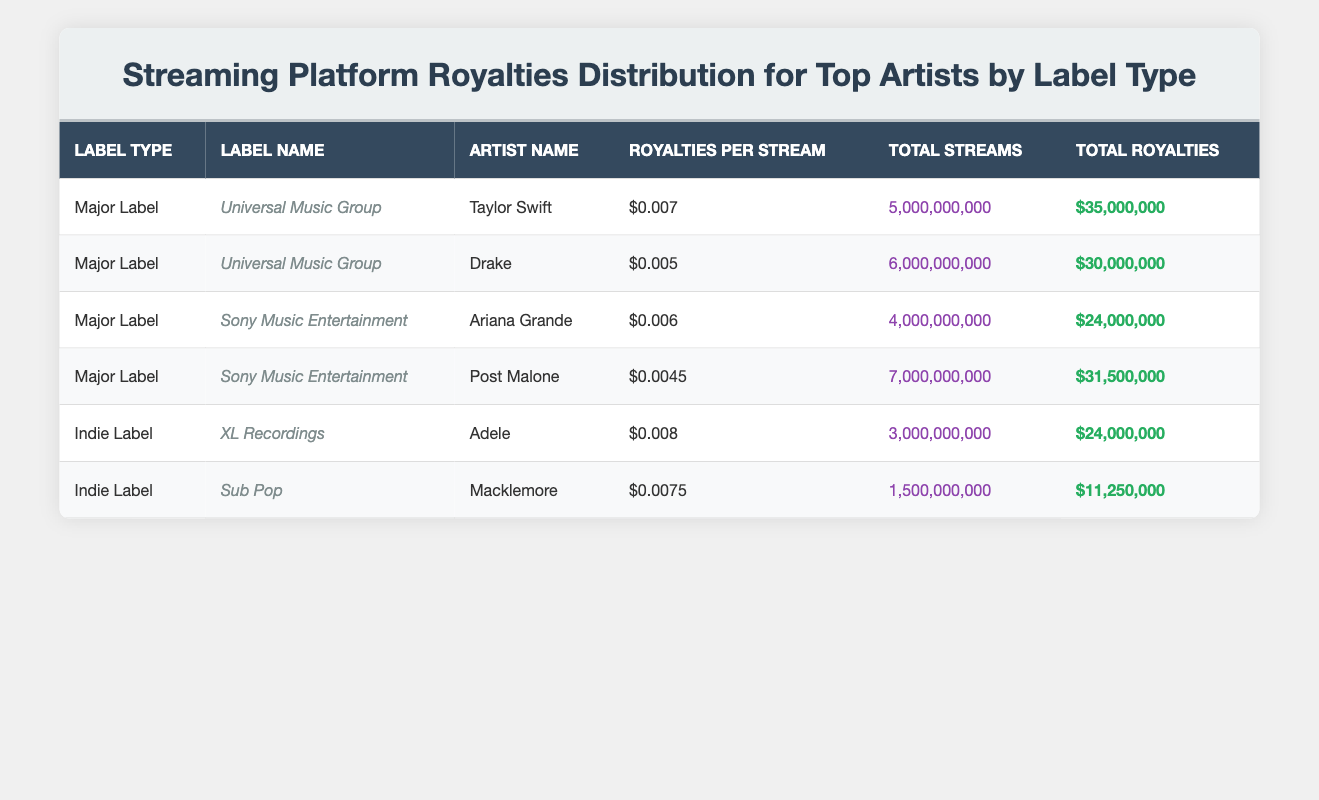What is the highest royalties per stream among the artists listed? From the table, the highest royalties per stream is $0.008, which is attributed to Adele under XL Recordings.
Answer: $0.008 Which artist from a Major Label has the lowest total royalties? Looking at the total royalties for the Major Label artists, Drake has total royalties of $30,000,000, which is the lowest when compared to Taylor Swift and Post Malone.
Answer: Drake How many total streams did all artists under Major Labels have combined? Adding the total streams from Major Labels: Taylor Swift (5,000,000,000) + Drake (6,000,000,000) + Ariana Grande (4,000,000,000) + Post Malone (7,000,000,000) gives a total of 22,000,000,000.
Answer: 22,000,000,000 Is it true that Macklemore made more total royalties than Taylor Swift? By comparing total royalties, Taylor Swift has $35,000,000, while Macklemore has $11,250,000. Since $35,000,000 is greater than $11,250,000, it is false that Macklemore made more.
Answer: No What is the average royalties per stream for Indie Label artists? The royalties per stream for Indie Label artists are $0.008 for Adele and $0.0075 for Macklemore, totaling $0.008 + $0.0075 = $0.015. Dividing by 2 (the number of artists) gives an average of $0.0075.
Answer: $0.0075 Which Major Label artist generates more total royalties, Ariana Grande or Post Malone? Ariana Grande has total royalties of $24,000,000, while Post Malone has $31,500,000. Therefore, Post Malone generates more total royalties than Ariana Grande.
Answer: Post Malone What is the total royalties for all artists under Indie Labels? Adding the total royalties from both Indie Label artists: Adele ($24,000,000) + Macklemore ($11,250,000) gives a total of $35,250,000 for Indie Labels.
Answer: $35,250,000 Which Major Label had the highest total streams for its top artist? Comparing the total streams, Universal Music Group's Taylor Swift has 5,000,000,000 and Sony Music Entertainment's Post Malone has 7,000,000,000. Thus, Sony Music Entertainment has the highest total streams for its top artist.
Answer: Sony Music Entertainment 